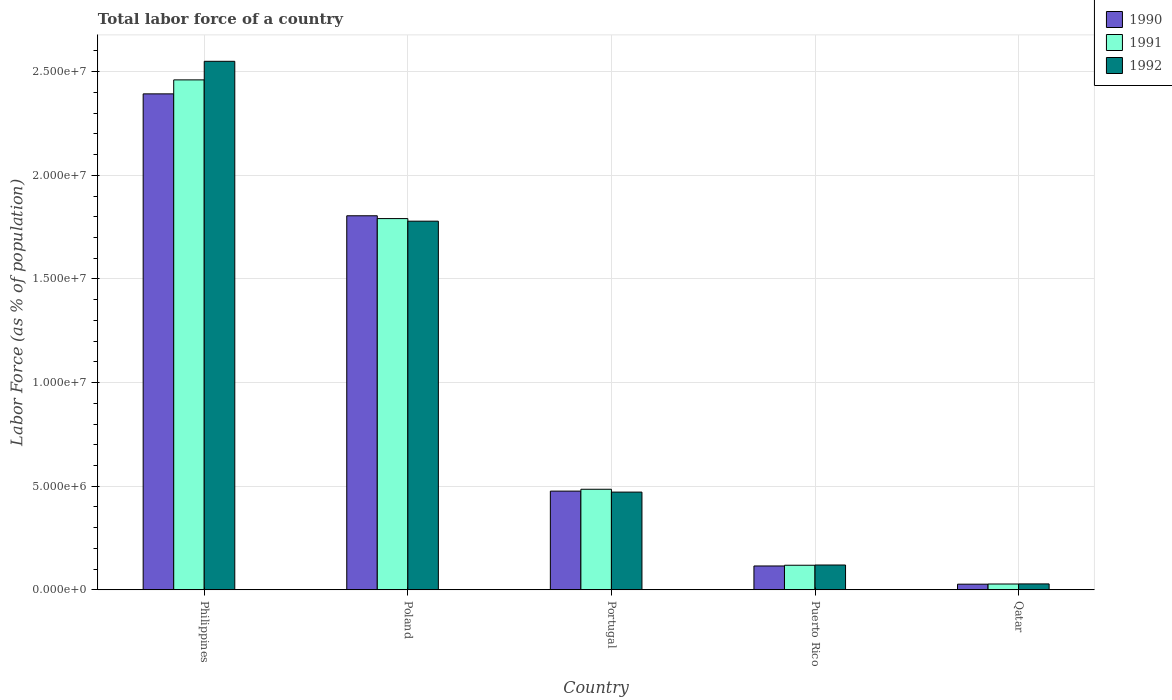How many different coloured bars are there?
Your answer should be compact. 3. How many groups of bars are there?
Give a very brief answer. 5. Are the number of bars on each tick of the X-axis equal?
Keep it short and to the point. Yes. In how many cases, is the number of bars for a given country not equal to the number of legend labels?
Your response must be concise. 0. What is the percentage of labor force in 1992 in Philippines?
Your response must be concise. 2.55e+07. Across all countries, what is the maximum percentage of labor force in 1991?
Your response must be concise. 2.46e+07. Across all countries, what is the minimum percentage of labor force in 1992?
Your answer should be very brief. 2.86e+05. In which country was the percentage of labor force in 1991 minimum?
Provide a short and direct response. Qatar. What is the total percentage of labor force in 1992 in the graph?
Your answer should be compact. 4.95e+07. What is the difference between the percentage of labor force in 1991 in Portugal and that in Puerto Rico?
Provide a short and direct response. 3.67e+06. What is the difference between the percentage of labor force in 1991 in Poland and the percentage of labor force in 1992 in Portugal?
Make the answer very short. 1.32e+07. What is the average percentage of labor force in 1992 per country?
Keep it short and to the point. 9.90e+06. What is the difference between the percentage of labor force of/in 1992 and percentage of labor force of/in 1991 in Puerto Rico?
Give a very brief answer. 1.12e+04. In how many countries, is the percentage of labor force in 1991 greater than 17000000 %?
Give a very brief answer. 2. What is the ratio of the percentage of labor force in 1991 in Philippines to that in Puerto Rico?
Your answer should be compact. 20.72. Is the percentage of labor force in 1992 in Portugal less than that in Puerto Rico?
Offer a terse response. No. Is the difference between the percentage of labor force in 1992 in Poland and Portugal greater than the difference between the percentage of labor force in 1991 in Poland and Portugal?
Provide a succinct answer. Yes. What is the difference between the highest and the second highest percentage of labor force in 1992?
Your response must be concise. -1.31e+07. What is the difference between the highest and the lowest percentage of labor force in 1991?
Make the answer very short. 2.43e+07. In how many countries, is the percentage of labor force in 1990 greater than the average percentage of labor force in 1990 taken over all countries?
Keep it short and to the point. 2. What does the 1st bar from the right in Portugal represents?
Give a very brief answer. 1992. How many countries are there in the graph?
Your answer should be very brief. 5. Are the values on the major ticks of Y-axis written in scientific E-notation?
Offer a terse response. Yes. Does the graph contain grids?
Your response must be concise. Yes. How are the legend labels stacked?
Provide a short and direct response. Vertical. What is the title of the graph?
Give a very brief answer. Total labor force of a country. What is the label or title of the Y-axis?
Offer a terse response. Labor Force (as % of population). What is the Labor Force (as % of population) of 1990 in Philippines?
Your answer should be compact. 2.39e+07. What is the Labor Force (as % of population) in 1991 in Philippines?
Provide a succinct answer. 2.46e+07. What is the Labor Force (as % of population) of 1992 in Philippines?
Offer a very short reply. 2.55e+07. What is the Labor Force (as % of population) in 1990 in Poland?
Your answer should be compact. 1.80e+07. What is the Labor Force (as % of population) of 1991 in Poland?
Your response must be concise. 1.79e+07. What is the Labor Force (as % of population) of 1992 in Poland?
Make the answer very short. 1.78e+07. What is the Labor Force (as % of population) in 1990 in Portugal?
Your response must be concise. 4.76e+06. What is the Labor Force (as % of population) of 1991 in Portugal?
Make the answer very short. 4.85e+06. What is the Labor Force (as % of population) in 1992 in Portugal?
Provide a short and direct response. 4.72e+06. What is the Labor Force (as % of population) in 1990 in Puerto Rico?
Offer a very short reply. 1.15e+06. What is the Labor Force (as % of population) in 1991 in Puerto Rico?
Give a very brief answer. 1.19e+06. What is the Labor Force (as % of population) of 1992 in Puerto Rico?
Your response must be concise. 1.20e+06. What is the Labor Force (as % of population) of 1990 in Qatar?
Your answer should be compact. 2.73e+05. What is the Labor Force (as % of population) of 1991 in Qatar?
Your response must be concise. 2.82e+05. What is the Labor Force (as % of population) of 1992 in Qatar?
Your response must be concise. 2.86e+05. Across all countries, what is the maximum Labor Force (as % of population) of 1990?
Your answer should be very brief. 2.39e+07. Across all countries, what is the maximum Labor Force (as % of population) of 1991?
Make the answer very short. 2.46e+07. Across all countries, what is the maximum Labor Force (as % of population) of 1992?
Ensure brevity in your answer.  2.55e+07. Across all countries, what is the minimum Labor Force (as % of population) of 1990?
Make the answer very short. 2.73e+05. Across all countries, what is the minimum Labor Force (as % of population) of 1991?
Make the answer very short. 2.82e+05. Across all countries, what is the minimum Labor Force (as % of population) in 1992?
Give a very brief answer. 2.86e+05. What is the total Labor Force (as % of population) in 1990 in the graph?
Provide a succinct answer. 4.82e+07. What is the total Labor Force (as % of population) in 1991 in the graph?
Ensure brevity in your answer.  4.88e+07. What is the total Labor Force (as % of population) in 1992 in the graph?
Ensure brevity in your answer.  4.95e+07. What is the difference between the Labor Force (as % of population) of 1990 in Philippines and that in Poland?
Provide a succinct answer. 5.88e+06. What is the difference between the Labor Force (as % of population) of 1991 in Philippines and that in Poland?
Provide a succinct answer. 6.69e+06. What is the difference between the Labor Force (as % of population) of 1992 in Philippines and that in Poland?
Provide a short and direct response. 7.71e+06. What is the difference between the Labor Force (as % of population) in 1990 in Philippines and that in Portugal?
Ensure brevity in your answer.  1.92e+07. What is the difference between the Labor Force (as % of population) of 1991 in Philippines and that in Portugal?
Your response must be concise. 1.97e+07. What is the difference between the Labor Force (as % of population) in 1992 in Philippines and that in Portugal?
Make the answer very short. 2.08e+07. What is the difference between the Labor Force (as % of population) of 1990 in Philippines and that in Puerto Rico?
Ensure brevity in your answer.  2.28e+07. What is the difference between the Labor Force (as % of population) in 1991 in Philippines and that in Puerto Rico?
Give a very brief answer. 2.34e+07. What is the difference between the Labor Force (as % of population) of 1992 in Philippines and that in Puerto Rico?
Keep it short and to the point. 2.43e+07. What is the difference between the Labor Force (as % of population) in 1990 in Philippines and that in Qatar?
Your answer should be compact. 2.37e+07. What is the difference between the Labor Force (as % of population) in 1991 in Philippines and that in Qatar?
Your answer should be very brief. 2.43e+07. What is the difference between the Labor Force (as % of population) of 1992 in Philippines and that in Qatar?
Ensure brevity in your answer.  2.52e+07. What is the difference between the Labor Force (as % of population) of 1990 in Poland and that in Portugal?
Keep it short and to the point. 1.33e+07. What is the difference between the Labor Force (as % of population) of 1991 in Poland and that in Portugal?
Offer a terse response. 1.31e+07. What is the difference between the Labor Force (as % of population) in 1992 in Poland and that in Portugal?
Offer a very short reply. 1.31e+07. What is the difference between the Labor Force (as % of population) in 1990 in Poland and that in Puerto Rico?
Your response must be concise. 1.69e+07. What is the difference between the Labor Force (as % of population) in 1991 in Poland and that in Puerto Rico?
Keep it short and to the point. 1.67e+07. What is the difference between the Labor Force (as % of population) in 1992 in Poland and that in Puerto Rico?
Ensure brevity in your answer.  1.66e+07. What is the difference between the Labor Force (as % of population) in 1990 in Poland and that in Qatar?
Offer a terse response. 1.78e+07. What is the difference between the Labor Force (as % of population) in 1991 in Poland and that in Qatar?
Your answer should be very brief. 1.76e+07. What is the difference between the Labor Force (as % of population) in 1992 in Poland and that in Qatar?
Keep it short and to the point. 1.75e+07. What is the difference between the Labor Force (as % of population) in 1990 in Portugal and that in Puerto Rico?
Your answer should be very brief. 3.61e+06. What is the difference between the Labor Force (as % of population) in 1991 in Portugal and that in Puerto Rico?
Give a very brief answer. 3.67e+06. What is the difference between the Labor Force (as % of population) of 1992 in Portugal and that in Puerto Rico?
Keep it short and to the point. 3.52e+06. What is the difference between the Labor Force (as % of population) of 1990 in Portugal and that in Qatar?
Your answer should be very brief. 4.49e+06. What is the difference between the Labor Force (as % of population) of 1991 in Portugal and that in Qatar?
Provide a succinct answer. 4.57e+06. What is the difference between the Labor Force (as % of population) of 1992 in Portugal and that in Qatar?
Make the answer very short. 4.43e+06. What is the difference between the Labor Force (as % of population) in 1990 in Puerto Rico and that in Qatar?
Offer a terse response. 8.78e+05. What is the difference between the Labor Force (as % of population) in 1991 in Puerto Rico and that in Qatar?
Provide a succinct answer. 9.06e+05. What is the difference between the Labor Force (as % of population) of 1992 in Puerto Rico and that in Qatar?
Keep it short and to the point. 9.13e+05. What is the difference between the Labor Force (as % of population) of 1990 in Philippines and the Labor Force (as % of population) of 1991 in Poland?
Give a very brief answer. 6.02e+06. What is the difference between the Labor Force (as % of population) of 1990 in Philippines and the Labor Force (as % of population) of 1992 in Poland?
Give a very brief answer. 6.14e+06. What is the difference between the Labor Force (as % of population) of 1991 in Philippines and the Labor Force (as % of population) of 1992 in Poland?
Your response must be concise. 6.82e+06. What is the difference between the Labor Force (as % of population) in 1990 in Philippines and the Labor Force (as % of population) in 1991 in Portugal?
Give a very brief answer. 1.91e+07. What is the difference between the Labor Force (as % of population) in 1990 in Philippines and the Labor Force (as % of population) in 1992 in Portugal?
Give a very brief answer. 1.92e+07. What is the difference between the Labor Force (as % of population) in 1991 in Philippines and the Labor Force (as % of population) in 1992 in Portugal?
Your response must be concise. 1.99e+07. What is the difference between the Labor Force (as % of population) of 1990 in Philippines and the Labor Force (as % of population) of 1991 in Puerto Rico?
Give a very brief answer. 2.27e+07. What is the difference between the Labor Force (as % of population) of 1990 in Philippines and the Labor Force (as % of population) of 1992 in Puerto Rico?
Your response must be concise. 2.27e+07. What is the difference between the Labor Force (as % of population) of 1991 in Philippines and the Labor Force (as % of population) of 1992 in Puerto Rico?
Provide a short and direct response. 2.34e+07. What is the difference between the Labor Force (as % of population) in 1990 in Philippines and the Labor Force (as % of population) in 1991 in Qatar?
Your answer should be very brief. 2.36e+07. What is the difference between the Labor Force (as % of population) in 1990 in Philippines and the Labor Force (as % of population) in 1992 in Qatar?
Your response must be concise. 2.36e+07. What is the difference between the Labor Force (as % of population) of 1991 in Philippines and the Labor Force (as % of population) of 1992 in Qatar?
Offer a terse response. 2.43e+07. What is the difference between the Labor Force (as % of population) of 1990 in Poland and the Labor Force (as % of population) of 1991 in Portugal?
Provide a short and direct response. 1.32e+07. What is the difference between the Labor Force (as % of population) in 1990 in Poland and the Labor Force (as % of population) in 1992 in Portugal?
Provide a short and direct response. 1.33e+07. What is the difference between the Labor Force (as % of population) in 1991 in Poland and the Labor Force (as % of population) in 1992 in Portugal?
Your answer should be very brief. 1.32e+07. What is the difference between the Labor Force (as % of population) in 1990 in Poland and the Labor Force (as % of population) in 1991 in Puerto Rico?
Keep it short and to the point. 1.69e+07. What is the difference between the Labor Force (as % of population) of 1990 in Poland and the Labor Force (as % of population) of 1992 in Puerto Rico?
Give a very brief answer. 1.68e+07. What is the difference between the Labor Force (as % of population) in 1991 in Poland and the Labor Force (as % of population) in 1992 in Puerto Rico?
Provide a succinct answer. 1.67e+07. What is the difference between the Labor Force (as % of population) in 1990 in Poland and the Labor Force (as % of population) in 1991 in Qatar?
Offer a very short reply. 1.78e+07. What is the difference between the Labor Force (as % of population) in 1990 in Poland and the Labor Force (as % of population) in 1992 in Qatar?
Give a very brief answer. 1.78e+07. What is the difference between the Labor Force (as % of population) of 1991 in Poland and the Labor Force (as % of population) of 1992 in Qatar?
Your answer should be very brief. 1.76e+07. What is the difference between the Labor Force (as % of population) of 1990 in Portugal and the Labor Force (as % of population) of 1991 in Puerto Rico?
Offer a very short reply. 3.58e+06. What is the difference between the Labor Force (as % of population) in 1990 in Portugal and the Labor Force (as % of population) in 1992 in Puerto Rico?
Make the answer very short. 3.56e+06. What is the difference between the Labor Force (as % of population) of 1991 in Portugal and the Labor Force (as % of population) of 1992 in Puerto Rico?
Your response must be concise. 3.65e+06. What is the difference between the Labor Force (as % of population) of 1990 in Portugal and the Labor Force (as % of population) of 1991 in Qatar?
Your answer should be compact. 4.48e+06. What is the difference between the Labor Force (as % of population) of 1990 in Portugal and the Labor Force (as % of population) of 1992 in Qatar?
Ensure brevity in your answer.  4.48e+06. What is the difference between the Labor Force (as % of population) in 1991 in Portugal and the Labor Force (as % of population) in 1992 in Qatar?
Ensure brevity in your answer.  4.57e+06. What is the difference between the Labor Force (as % of population) in 1990 in Puerto Rico and the Labor Force (as % of population) in 1991 in Qatar?
Make the answer very short. 8.70e+05. What is the difference between the Labor Force (as % of population) of 1990 in Puerto Rico and the Labor Force (as % of population) of 1992 in Qatar?
Your answer should be very brief. 8.66e+05. What is the difference between the Labor Force (as % of population) of 1991 in Puerto Rico and the Labor Force (as % of population) of 1992 in Qatar?
Your answer should be very brief. 9.01e+05. What is the average Labor Force (as % of population) in 1990 per country?
Keep it short and to the point. 9.63e+06. What is the average Labor Force (as % of population) in 1991 per country?
Make the answer very short. 9.77e+06. What is the average Labor Force (as % of population) of 1992 per country?
Keep it short and to the point. 9.90e+06. What is the difference between the Labor Force (as % of population) in 1990 and Labor Force (as % of population) in 1991 in Philippines?
Provide a succinct answer. -6.75e+05. What is the difference between the Labor Force (as % of population) of 1990 and Labor Force (as % of population) of 1992 in Philippines?
Give a very brief answer. -1.57e+06. What is the difference between the Labor Force (as % of population) in 1991 and Labor Force (as % of population) in 1992 in Philippines?
Your response must be concise. -8.96e+05. What is the difference between the Labor Force (as % of population) of 1990 and Labor Force (as % of population) of 1991 in Poland?
Offer a terse response. 1.35e+05. What is the difference between the Labor Force (as % of population) in 1990 and Labor Force (as % of population) in 1992 in Poland?
Make the answer very short. 2.60e+05. What is the difference between the Labor Force (as % of population) in 1991 and Labor Force (as % of population) in 1992 in Poland?
Give a very brief answer. 1.25e+05. What is the difference between the Labor Force (as % of population) in 1990 and Labor Force (as % of population) in 1991 in Portugal?
Provide a short and direct response. -8.97e+04. What is the difference between the Labor Force (as % of population) of 1990 and Labor Force (as % of population) of 1992 in Portugal?
Provide a short and direct response. 4.76e+04. What is the difference between the Labor Force (as % of population) of 1991 and Labor Force (as % of population) of 1992 in Portugal?
Your answer should be compact. 1.37e+05. What is the difference between the Labor Force (as % of population) in 1990 and Labor Force (as % of population) in 1991 in Puerto Rico?
Provide a succinct answer. -3.57e+04. What is the difference between the Labor Force (as % of population) in 1990 and Labor Force (as % of population) in 1992 in Puerto Rico?
Ensure brevity in your answer.  -4.69e+04. What is the difference between the Labor Force (as % of population) in 1991 and Labor Force (as % of population) in 1992 in Puerto Rico?
Offer a very short reply. -1.12e+04. What is the difference between the Labor Force (as % of population) in 1990 and Labor Force (as % of population) in 1991 in Qatar?
Make the answer very short. -8534. What is the difference between the Labor Force (as % of population) in 1990 and Labor Force (as % of population) in 1992 in Qatar?
Offer a terse response. -1.27e+04. What is the difference between the Labor Force (as % of population) of 1991 and Labor Force (as % of population) of 1992 in Qatar?
Your answer should be very brief. -4192. What is the ratio of the Labor Force (as % of population) of 1990 in Philippines to that in Poland?
Your answer should be very brief. 1.33. What is the ratio of the Labor Force (as % of population) of 1991 in Philippines to that in Poland?
Provide a succinct answer. 1.37. What is the ratio of the Labor Force (as % of population) of 1992 in Philippines to that in Poland?
Offer a very short reply. 1.43. What is the ratio of the Labor Force (as % of population) of 1990 in Philippines to that in Portugal?
Give a very brief answer. 5.02. What is the ratio of the Labor Force (as % of population) of 1991 in Philippines to that in Portugal?
Make the answer very short. 5.07. What is the ratio of the Labor Force (as % of population) of 1992 in Philippines to that in Portugal?
Your answer should be very brief. 5.41. What is the ratio of the Labor Force (as % of population) in 1990 in Philippines to that in Puerto Rico?
Make the answer very short. 20.78. What is the ratio of the Labor Force (as % of population) of 1991 in Philippines to that in Puerto Rico?
Your response must be concise. 20.72. What is the ratio of the Labor Force (as % of population) in 1992 in Philippines to that in Puerto Rico?
Provide a succinct answer. 21.28. What is the ratio of the Labor Force (as % of population) of 1990 in Philippines to that in Qatar?
Your response must be concise. 87.6. What is the ratio of the Labor Force (as % of population) of 1991 in Philippines to that in Qatar?
Your answer should be compact. 87.34. What is the ratio of the Labor Force (as % of population) in 1992 in Philippines to that in Qatar?
Your response must be concise. 89.2. What is the ratio of the Labor Force (as % of population) in 1990 in Poland to that in Portugal?
Keep it short and to the point. 3.79. What is the ratio of the Labor Force (as % of population) in 1991 in Poland to that in Portugal?
Your answer should be compact. 3.69. What is the ratio of the Labor Force (as % of population) of 1992 in Poland to that in Portugal?
Offer a very short reply. 3.77. What is the ratio of the Labor Force (as % of population) of 1990 in Poland to that in Puerto Rico?
Your answer should be compact. 15.67. What is the ratio of the Labor Force (as % of population) of 1991 in Poland to that in Puerto Rico?
Offer a very short reply. 15.09. What is the ratio of the Labor Force (as % of population) in 1992 in Poland to that in Puerto Rico?
Keep it short and to the point. 14.84. What is the ratio of the Labor Force (as % of population) in 1990 in Poland to that in Qatar?
Offer a very short reply. 66.07. What is the ratio of the Labor Force (as % of population) of 1991 in Poland to that in Qatar?
Ensure brevity in your answer.  63.59. What is the ratio of the Labor Force (as % of population) in 1992 in Poland to that in Qatar?
Offer a terse response. 62.22. What is the ratio of the Labor Force (as % of population) in 1990 in Portugal to that in Puerto Rico?
Give a very brief answer. 4.14. What is the ratio of the Labor Force (as % of population) of 1991 in Portugal to that in Puerto Rico?
Give a very brief answer. 4.09. What is the ratio of the Labor Force (as % of population) of 1992 in Portugal to that in Puerto Rico?
Your response must be concise. 3.93. What is the ratio of the Labor Force (as % of population) in 1990 in Portugal to that in Qatar?
Keep it short and to the point. 17.44. What is the ratio of the Labor Force (as % of population) of 1991 in Portugal to that in Qatar?
Ensure brevity in your answer.  17.23. What is the ratio of the Labor Force (as % of population) in 1992 in Portugal to that in Qatar?
Provide a succinct answer. 16.49. What is the ratio of the Labor Force (as % of population) in 1990 in Puerto Rico to that in Qatar?
Your answer should be compact. 4.22. What is the ratio of the Labor Force (as % of population) of 1991 in Puerto Rico to that in Qatar?
Make the answer very short. 4.21. What is the ratio of the Labor Force (as % of population) of 1992 in Puerto Rico to that in Qatar?
Offer a terse response. 4.19. What is the difference between the highest and the second highest Labor Force (as % of population) of 1990?
Offer a very short reply. 5.88e+06. What is the difference between the highest and the second highest Labor Force (as % of population) in 1991?
Your response must be concise. 6.69e+06. What is the difference between the highest and the second highest Labor Force (as % of population) in 1992?
Offer a terse response. 7.71e+06. What is the difference between the highest and the lowest Labor Force (as % of population) in 1990?
Provide a succinct answer. 2.37e+07. What is the difference between the highest and the lowest Labor Force (as % of population) in 1991?
Offer a very short reply. 2.43e+07. What is the difference between the highest and the lowest Labor Force (as % of population) in 1992?
Offer a very short reply. 2.52e+07. 